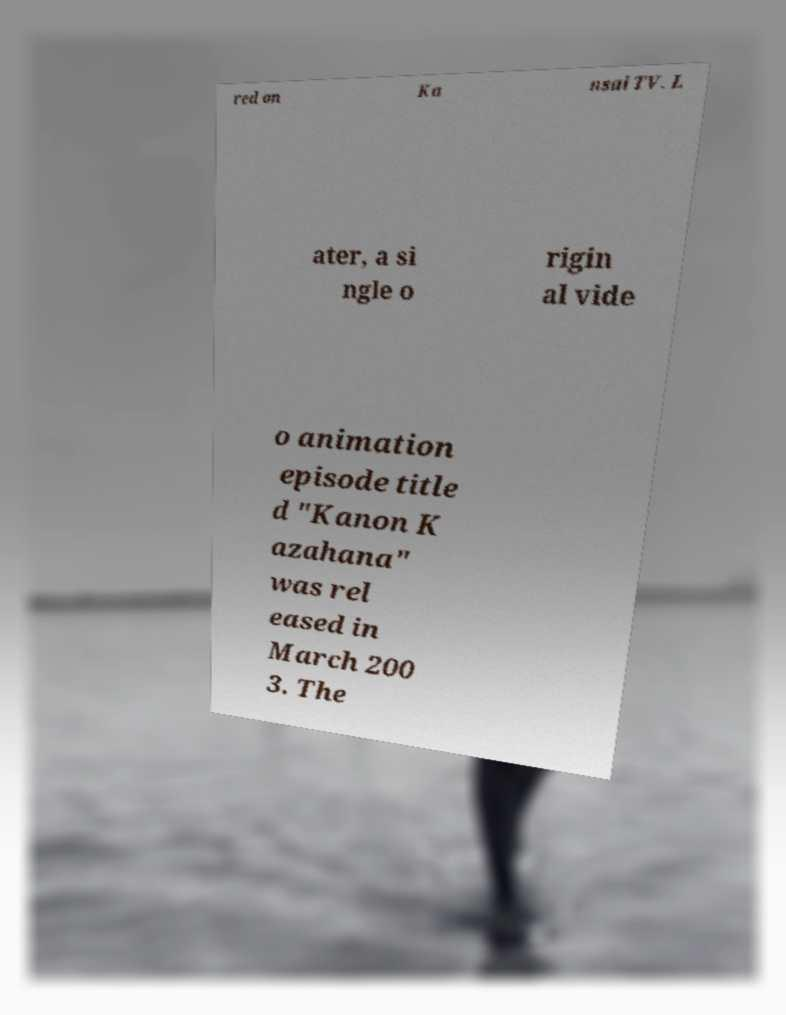There's text embedded in this image that I need extracted. Can you transcribe it verbatim? red on Ka nsai TV. L ater, a si ngle o rigin al vide o animation episode title d "Kanon K azahana" was rel eased in March 200 3. The 